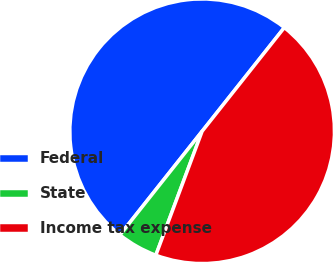<chart> <loc_0><loc_0><loc_500><loc_500><pie_chart><fcel>Federal<fcel>State<fcel>Income tax expense<nl><fcel>50.0%<fcel>4.98%<fcel>45.02%<nl></chart> 